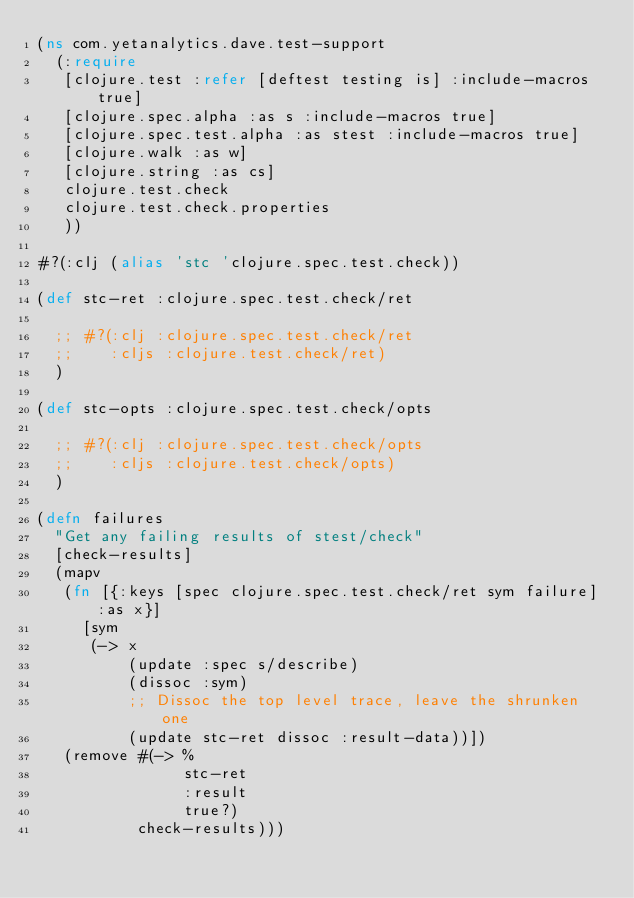Convert code to text. <code><loc_0><loc_0><loc_500><loc_500><_Clojure_>(ns com.yetanalytics.dave.test-support
  (:require
   [clojure.test :refer [deftest testing is] :include-macros true]
   [clojure.spec.alpha :as s :include-macros true]
   [clojure.spec.test.alpha :as stest :include-macros true]
   [clojure.walk :as w]
   [clojure.string :as cs]
   clojure.test.check
   clojure.test.check.properties
   ))

#?(:clj (alias 'stc 'clojure.spec.test.check))

(def stc-ret :clojure.spec.test.check/ret

  ;; #?(:clj :clojure.spec.test.check/ret
  ;;    :cljs :clojure.test.check/ret)
  )

(def stc-opts :clojure.spec.test.check/opts

  ;; #?(:clj :clojure.spec.test.check/opts
  ;;    :cljs :clojure.test.check/opts)
  )

(defn failures
  "Get any failing results of stest/check"
  [check-results]
  (mapv
   (fn [{:keys [spec clojure.spec.test.check/ret sym failure] :as x}]
     [sym
      (-> x
          (update :spec s/describe)
          (dissoc :sym)
          ;; Dissoc the top level trace, leave the shrunken one
          (update stc-ret dissoc :result-data))])
   (remove #(-> %
                stc-ret
                :result
                true?)
           check-results)))
</code> 